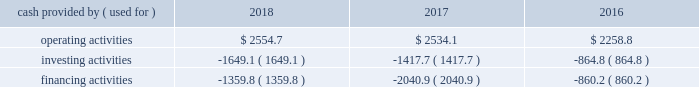Liquidity and capital resources we maintained a strong financial position throughout 2018 and as of 30 september 2018 our consolidated balance sheet included cash and cash items of $ 2791.3 .
We continue to have consistent access to commercial paper markets , and cash flows from operating and financing activities are expected to meet liquidity needs for the foreseeable future .
As of 30 september 2018 , we had $ 995.1 of foreign cash and cash items compared to a total amount of cash and cash items of $ 2791.3 .
As a result of the tax act , we currently do not expect that a significant portion of the earnings of our foreign subsidiaries and affiliates will be subject to u.s .
Income tax upon subsequent repatriation to the united states .
Depending on the country in which the subsidiaries and affiliates reside , the repatriation of these earnings may be subject to foreign withholding and other taxes .
However , since we have significant current investment plans outside the u.s. , it is our intent to permanently reinvest the majority of our foreign cash and cash items that would be subject to additional taxes outside the u.s .
Refer to note 22 , income taxes , for additional information .
Our cash flows from operating , investing , and financing activities from continuing operations , as reflected in the consolidated statements of cash flows , are summarized in the table: .
Operating activities for the year ended 2018 , cash provided by operating activities was $ 2554.7 .
Income from continuing operations of $ 1455.6 was adjusted for items including depreciation and amortization , deferred income taxes , impacts from the tax act , undistributed earnings of unconsolidated affiliates , share-based compensation , and noncurrent capital lease receivables .
Other adjustments of $ 131.6 include a $ 54.9 net impact from the remeasurement of intercompany transactions .
The related hedging instruments that eliminate the earnings impact are included as a working capital adjustment in other receivables or payables and accrued liabilities .
In addition , other adjustments were impacted by cash received from the early termination of a cross currency swap of $ 54.4 , as well as the excess of pension expense over pension contributions of $ 23.5 .
The working capital accounts were a use of cash of $ 265.4 , primarily driven by payables and accrued liabilities , inventories , and trade receivables , partially offset by other receivables .
The use of cash in payables and accrued liabilities of $ 277.7 includes a decrease in customer advances of $ 145.7 primarily related to sale of equipment activity and $ 67.1 for maturities of forward exchange contracts that hedged foreign currency exposures .
The use of cash in inventories primarily resulted from the purchase of helium molecules .
In addition , inventories reflect the noncash impact of our change in accounting for u.s .
Inventories from lifo to fifo .
The source of cash from other receivables of $ 123.6 was primarily due to the maturities of forward exchange contracts that hedged foreign currency exposures for the year ended 2017 , cash provided by operating activities was $ 2534.1 .
Income from continuing operations of $ 1134.4 included a goodwill and intangible asset impairment charge of $ 162.1 , an equity method investment impairment charge of $ 79.5 , and a write-down of long-lived assets associated with restructuring of $ 69.2 .
Refer to note 5 , cost reduction and asset actions ; note 8 , summarized financial information of equity affiliates ; note 10 , goodwill ; and note 11 , intangible assets , of the consolidated financial statements for additional information on these charges .
Other adjustments of $ 165.4 included changes in uncertain tax positions and the fair value of foreign exchange contracts that hedge intercompany loans as well as pension contributions and expense .
The working capital accounts were a source of cash of $ 48.0 that were primarily driven by payables and accrued liabilities and other receivables , partially offset by other working capital and trade receivables .
The increase in payables and accrued liabilities of $ 163.8 was primarily due to timing differences related to payables and accrued liabilities and an increase in customer advances of $ 52.8 primarily related to sale of equipment activity .
The source of cash from other receivables of $ 124.7 was primarily due to the maturities of forward exchange contracts that hedged foreign currency exposures .
Other working capital was a use of cash of $ 154.0 , primarily driven by payments for income taxes .
Trade receivables was a use of cash of $ 73.6 which is primarily due to timing differences. .
What is the final amount of cash and cash equivalents in 2018? 
Rationale: it is the operating activities minus the investing and financing activities of the year 2018 .
Computations: ((2554.7 - 1649.1) - 1359.8)
Answer: -454.2. Liquidity and capital resources we maintained a strong financial position throughout 2018 and as of 30 september 2018 our consolidated balance sheet included cash and cash items of $ 2791.3 .
We continue to have consistent access to commercial paper markets , and cash flows from operating and financing activities are expected to meet liquidity needs for the foreseeable future .
As of 30 september 2018 , we had $ 995.1 of foreign cash and cash items compared to a total amount of cash and cash items of $ 2791.3 .
As a result of the tax act , we currently do not expect that a significant portion of the earnings of our foreign subsidiaries and affiliates will be subject to u.s .
Income tax upon subsequent repatriation to the united states .
Depending on the country in which the subsidiaries and affiliates reside , the repatriation of these earnings may be subject to foreign withholding and other taxes .
However , since we have significant current investment plans outside the u.s. , it is our intent to permanently reinvest the majority of our foreign cash and cash items that would be subject to additional taxes outside the u.s .
Refer to note 22 , income taxes , for additional information .
Our cash flows from operating , investing , and financing activities from continuing operations , as reflected in the consolidated statements of cash flows , are summarized in the table: .
Operating activities for the year ended 2018 , cash provided by operating activities was $ 2554.7 .
Income from continuing operations of $ 1455.6 was adjusted for items including depreciation and amortization , deferred income taxes , impacts from the tax act , undistributed earnings of unconsolidated affiliates , share-based compensation , and noncurrent capital lease receivables .
Other adjustments of $ 131.6 include a $ 54.9 net impact from the remeasurement of intercompany transactions .
The related hedging instruments that eliminate the earnings impact are included as a working capital adjustment in other receivables or payables and accrued liabilities .
In addition , other adjustments were impacted by cash received from the early termination of a cross currency swap of $ 54.4 , as well as the excess of pension expense over pension contributions of $ 23.5 .
The working capital accounts were a use of cash of $ 265.4 , primarily driven by payables and accrued liabilities , inventories , and trade receivables , partially offset by other receivables .
The use of cash in payables and accrued liabilities of $ 277.7 includes a decrease in customer advances of $ 145.7 primarily related to sale of equipment activity and $ 67.1 for maturities of forward exchange contracts that hedged foreign currency exposures .
The use of cash in inventories primarily resulted from the purchase of helium molecules .
In addition , inventories reflect the noncash impact of our change in accounting for u.s .
Inventories from lifo to fifo .
The source of cash from other receivables of $ 123.6 was primarily due to the maturities of forward exchange contracts that hedged foreign currency exposures for the year ended 2017 , cash provided by operating activities was $ 2534.1 .
Income from continuing operations of $ 1134.4 included a goodwill and intangible asset impairment charge of $ 162.1 , an equity method investment impairment charge of $ 79.5 , and a write-down of long-lived assets associated with restructuring of $ 69.2 .
Refer to note 5 , cost reduction and asset actions ; note 8 , summarized financial information of equity affiliates ; note 10 , goodwill ; and note 11 , intangible assets , of the consolidated financial statements for additional information on these charges .
Other adjustments of $ 165.4 included changes in uncertain tax positions and the fair value of foreign exchange contracts that hedge intercompany loans as well as pension contributions and expense .
The working capital accounts were a source of cash of $ 48.0 that were primarily driven by payables and accrued liabilities and other receivables , partially offset by other working capital and trade receivables .
The increase in payables and accrued liabilities of $ 163.8 was primarily due to timing differences related to payables and accrued liabilities and an increase in customer advances of $ 52.8 primarily related to sale of equipment activity .
The source of cash from other receivables of $ 124.7 was primarily due to the maturities of forward exchange contracts that hedged foreign currency exposures .
Other working capital was a use of cash of $ 154.0 , primarily driven by payments for income taxes .
Trade receivables was a use of cash of $ 73.6 which is primarily due to timing differences. .
What is the final amount of cash and cash equivalents in 2016? 
Rationale: it is the operating activities minus the investing and financing activities of the year 2016 .
Computations: ((2258.8 - 864.8) - 860.2)
Answer: 533.8. 